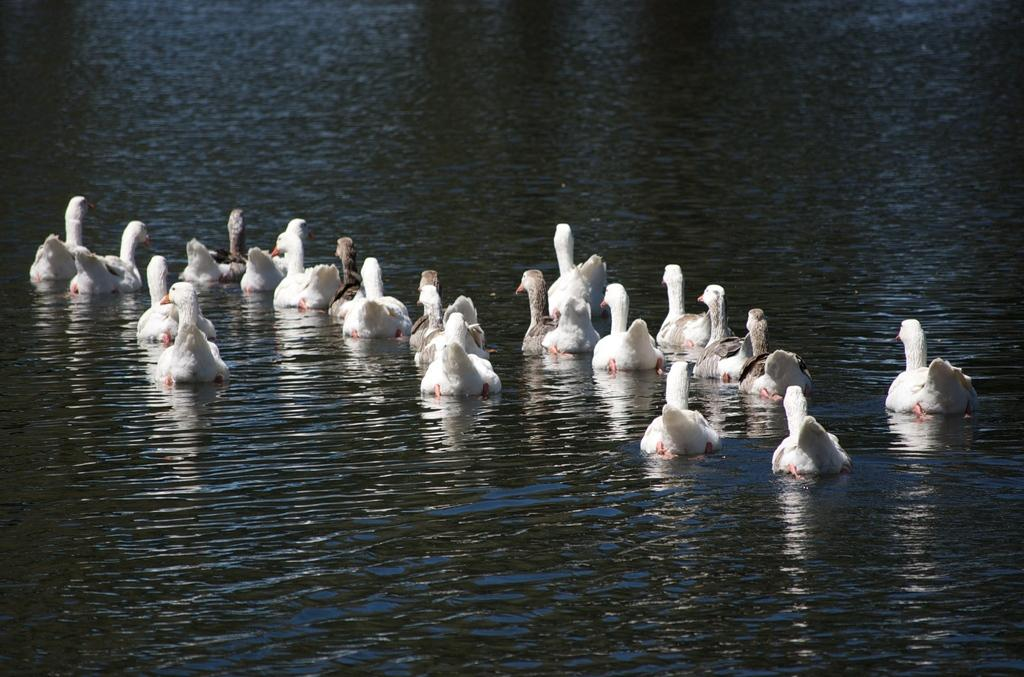What is present in the image that is not a bird or a bird-related feature? There is water visible in the image. What type of animals can be seen in the image? Birds can be seen in the image. What colors do the birds in the image have? The birds in the image have various colors, including white, red, black, and brown. What type of lumber is being used to construct the sail in the image? There is no sail present in the image, so it is not possible to determine what type of lumber might be used for its construction. 